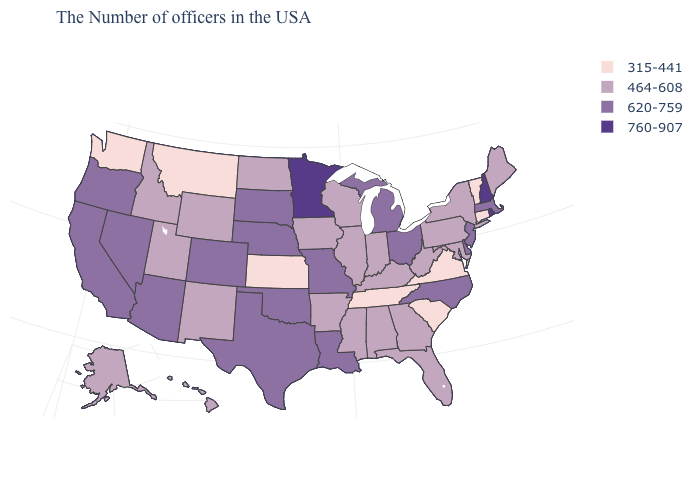Name the states that have a value in the range 620-759?
Be succinct. Massachusetts, New Jersey, Delaware, North Carolina, Ohio, Michigan, Louisiana, Missouri, Nebraska, Oklahoma, Texas, South Dakota, Colorado, Arizona, Nevada, California, Oregon. What is the value of South Carolina?
Answer briefly. 315-441. Which states have the lowest value in the USA?
Quick response, please. Vermont, Connecticut, Virginia, South Carolina, Tennessee, Kansas, Montana, Washington. What is the lowest value in the USA?
Keep it brief. 315-441. Does Ohio have the same value as Nebraska?
Be succinct. Yes. Among the states that border South Carolina , which have the lowest value?
Write a very short answer. Georgia. Name the states that have a value in the range 620-759?
Answer briefly. Massachusetts, New Jersey, Delaware, North Carolina, Ohio, Michigan, Louisiana, Missouri, Nebraska, Oklahoma, Texas, South Dakota, Colorado, Arizona, Nevada, California, Oregon. What is the value of Alabama?
Short answer required. 464-608. Which states have the lowest value in the West?
Answer briefly. Montana, Washington. What is the value of Indiana?
Quick response, please. 464-608. Which states have the lowest value in the South?
Concise answer only. Virginia, South Carolina, Tennessee. Among the states that border New York , which have the highest value?
Concise answer only. Massachusetts, New Jersey. Does New Hampshire have the highest value in the Northeast?
Concise answer only. Yes. What is the value of Montana?
Concise answer only. 315-441. 